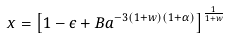Convert formula to latex. <formula><loc_0><loc_0><loc_500><loc_500>x = \left [ 1 - \epsilon + B a ^ { - 3 ( 1 + w ) ( 1 + \alpha ) } \right ] ^ { \frac { 1 } { 1 + w } }</formula> 